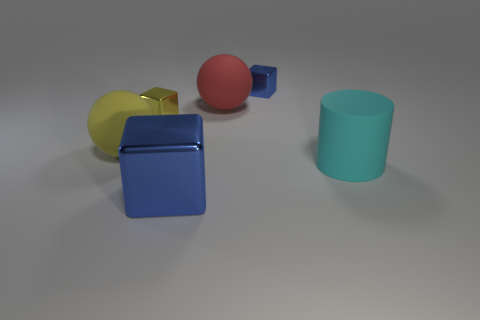How would you describe the lighting and shadows in the image? The image features a soft and diffused lighting setup that creates gentle shadows beneath the objects. The direction of the shadows suggests a light source coming from the top left of the scene, imparting a calm and uniform ambiance. 